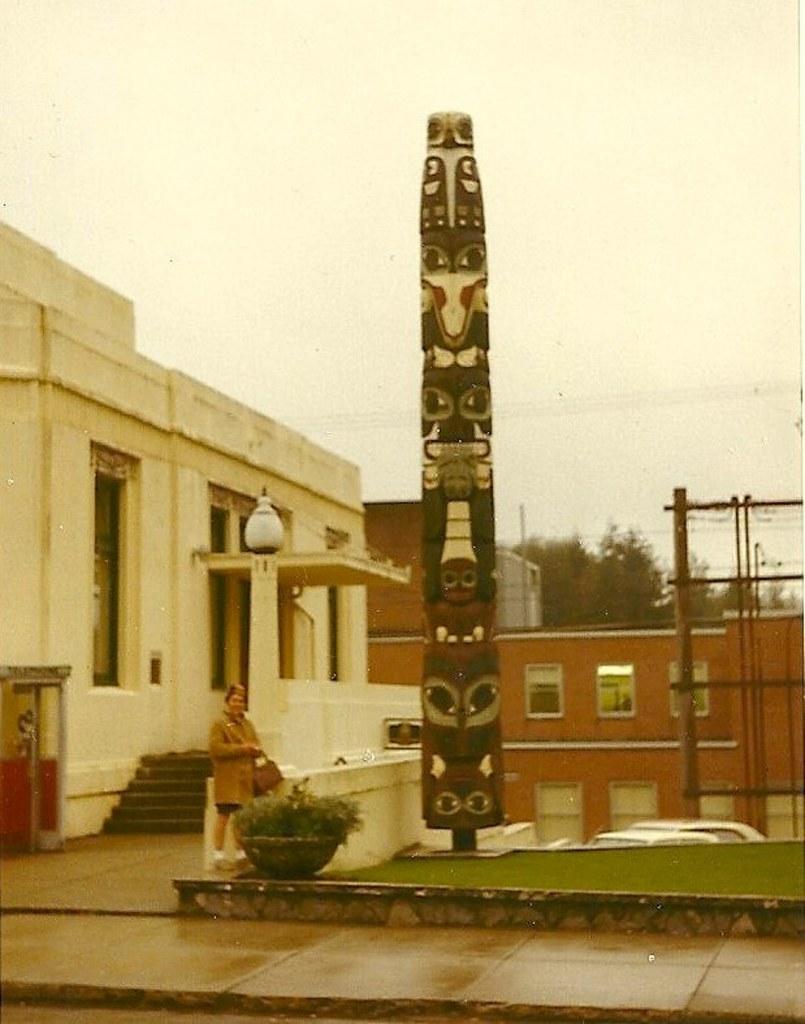Please provide a concise description of this image. In this image we can see a person standing and to the side there is a statue and we can see potted plant. There are some buildings and trees and at the top we can see the sky. 